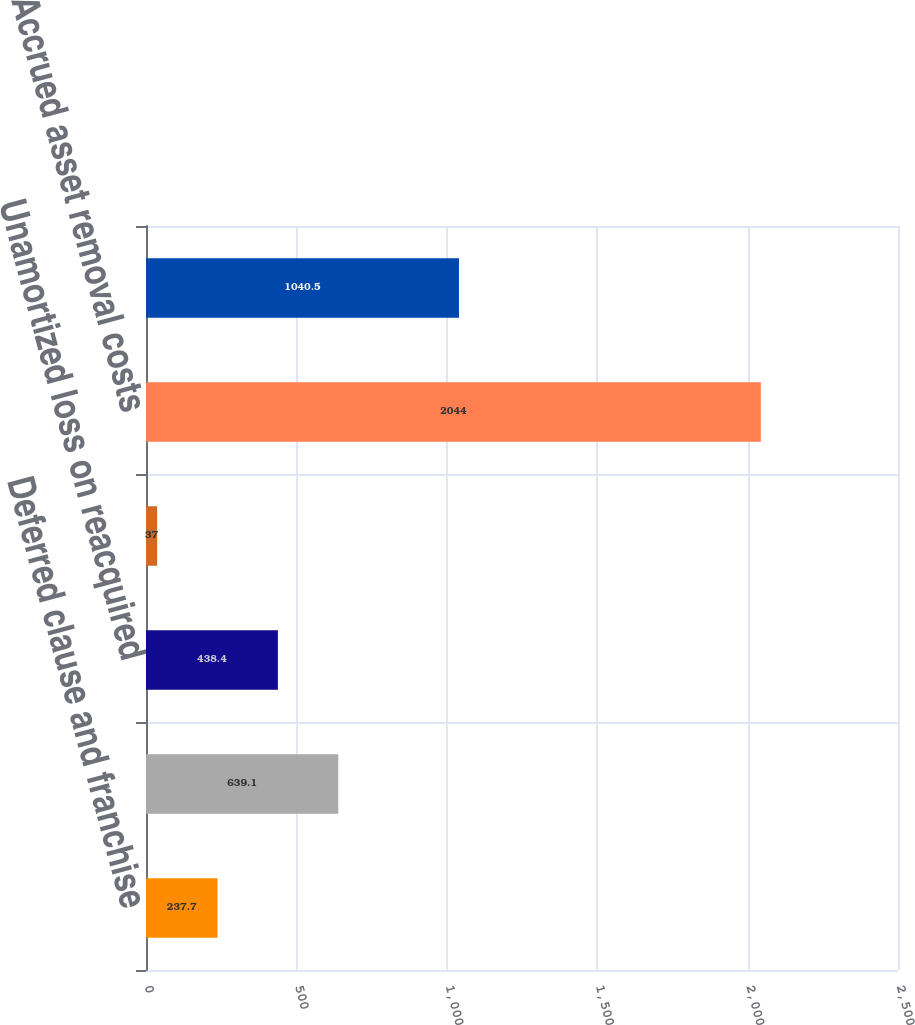Convert chart to OTSL. <chart><loc_0><loc_0><loc_500><loc_500><bar_chart><fcel>Deferred clause and franchise<fcel>Storm reserve deficiency<fcel>Unamortized loss on reacquired<fcel>Other<fcel>Accrued asset removal costs<fcel>Asset retirement obligation<nl><fcel>237.7<fcel>639.1<fcel>438.4<fcel>37<fcel>2044<fcel>1040.5<nl></chart> 